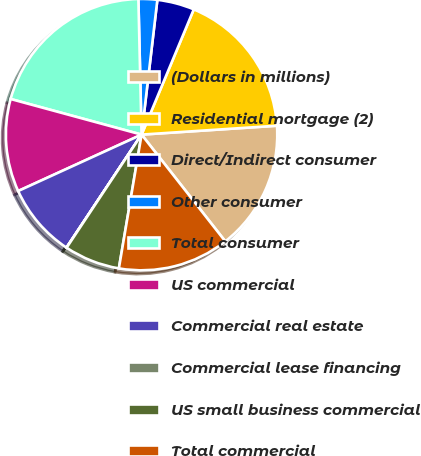Convert chart to OTSL. <chart><loc_0><loc_0><loc_500><loc_500><pie_chart><fcel>(Dollars in millions)<fcel>Residential mortgage (2)<fcel>Direct/Indirect consumer<fcel>Other consumer<fcel>Total consumer<fcel>US commercial<fcel>Commercial real estate<fcel>Commercial lease financing<fcel>US small business commercial<fcel>Total commercial<nl><fcel>15.46%<fcel>17.67%<fcel>4.43%<fcel>2.23%<fcel>20.4%<fcel>11.05%<fcel>8.84%<fcel>0.02%<fcel>6.64%<fcel>13.26%<nl></chart> 